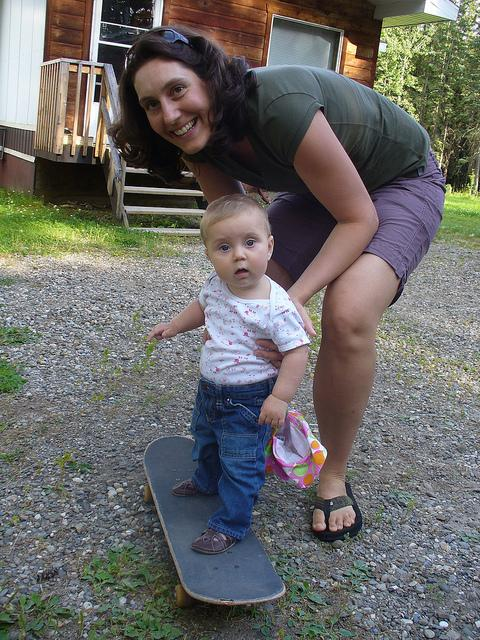What brand of sandals is the woman wearing?

Choices:
A) adidas
B) nike
C) reef
D) pacsun reef 